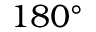<formula> <loc_0><loc_0><loc_500><loc_500>1 8 0 ^ { \circ }</formula> 